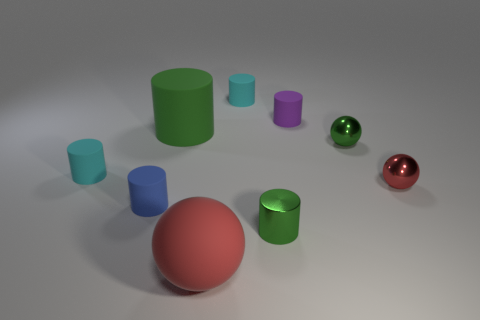Subtract all purple cylinders. How many cylinders are left? 5 Subtract all small metal cylinders. How many cylinders are left? 5 Subtract 2 cylinders. How many cylinders are left? 4 Subtract all brown cylinders. Subtract all cyan blocks. How many cylinders are left? 6 Add 1 big red metallic cubes. How many objects exist? 10 Subtract all spheres. How many objects are left? 6 Subtract all green metallic spheres. Subtract all cyan cylinders. How many objects are left? 6 Add 4 tiny cyan cylinders. How many tiny cyan cylinders are left? 6 Add 6 tiny rubber cylinders. How many tiny rubber cylinders exist? 10 Subtract 0 brown balls. How many objects are left? 9 